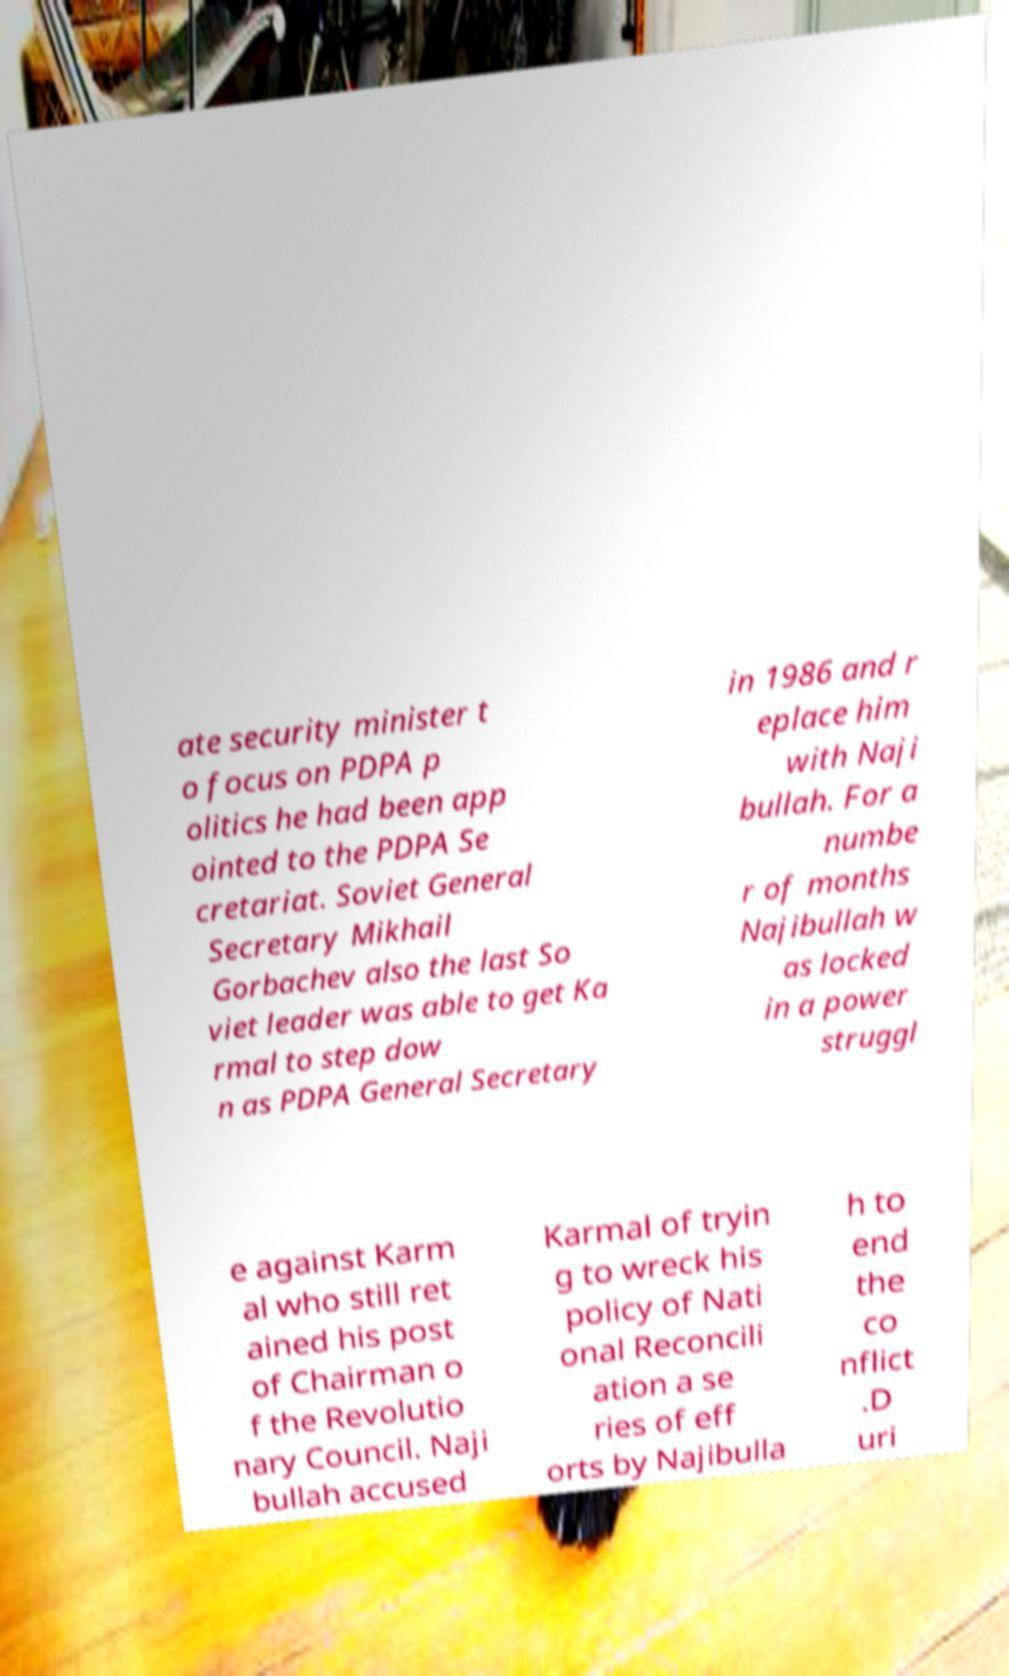What messages or text are displayed in this image? I need them in a readable, typed format. ate security minister t o focus on PDPA p olitics he had been app ointed to the PDPA Se cretariat. Soviet General Secretary Mikhail Gorbachev also the last So viet leader was able to get Ka rmal to step dow n as PDPA General Secretary in 1986 and r eplace him with Naji bullah. For a numbe r of months Najibullah w as locked in a power struggl e against Karm al who still ret ained his post of Chairman o f the Revolutio nary Council. Naji bullah accused Karmal of tryin g to wreck his policy of Nati onal Reconcili ation a se ries of eff orts by Najibulla h to end the co nflict .D uri 